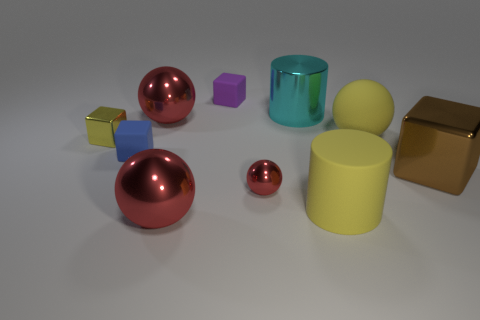Can you describe the lighting in the scene? The lighting in the scene appears to be soft and diffused, with no harsh shadows, suggesting an even spread of light, possibly from an overhead source. This type of lighting minimizes the contrast and allows the colors and materials of the objects to be observed clearly. 